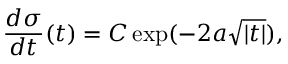<formula> <loc_0><loc_0><loc_500><loc_500>{ \frac { d \sigma } { d t } } ( t ) = C \exp ( - 2 a \sqrt { | t | } ) ,</formula> 